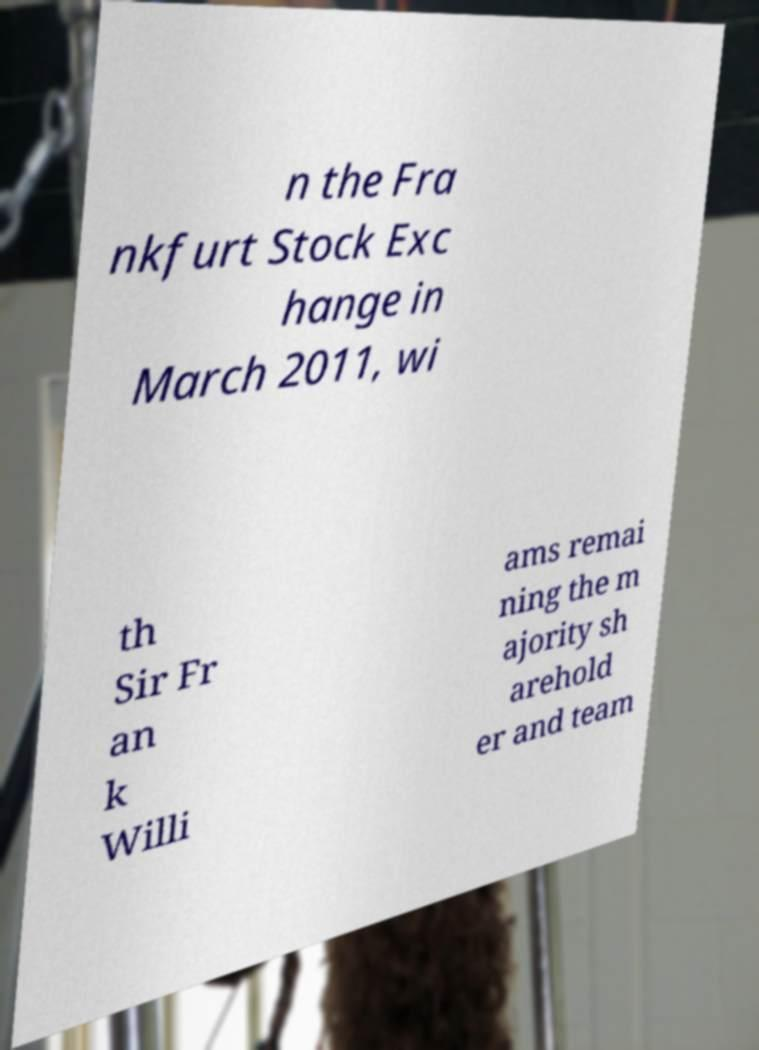For documentation purposes, I need the text within this image transcribed. Could you provide that? n the Fra nkfurt Stock Exc hange in March 2011, wi th Sir Fr an k Willi ams remai ning the m ajority sh arehold er and team 